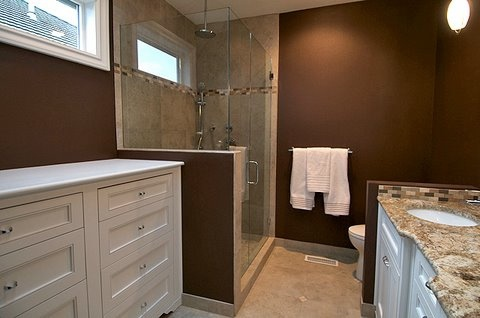Describe the objects in this image and their specific colors. I can see sink in darkgray, tan, and gray tones and toilet in darkgray, gray, and tan tones in this image. 